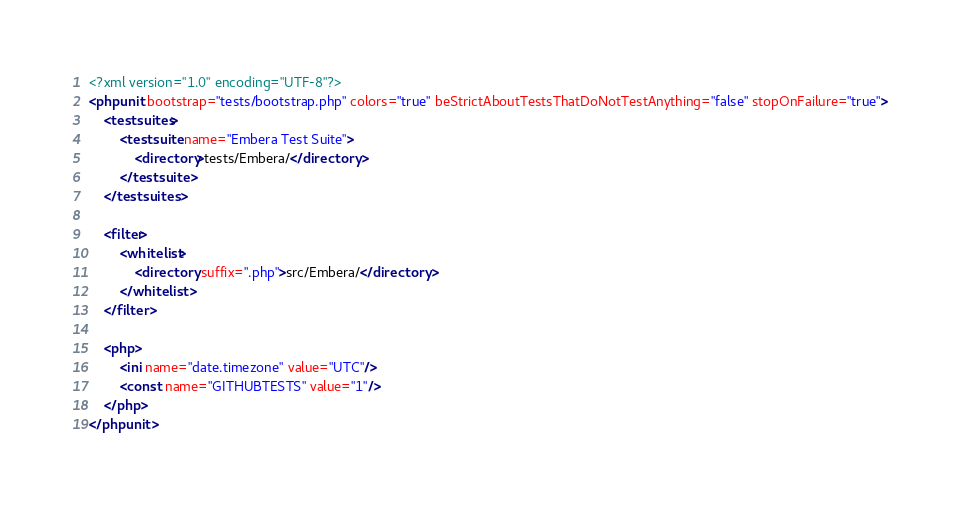Convert code to text. <code><loc_0><loc_0><loc_500><loc_500><_XML_><?xml version="1.0" encoding="UTF-8"?>
<phpunit bootstrap="tests/bootstrap.php" colors="true" beStrictAboutTestsThatDoNotTestAnything="false" stopOnFailure="true">
    <testsuites>
        <testsuite name="Embera Test Suite">
            <directory>tests/Embera/</directory>
        </testsuite>
    </testsuites>

    <filter>
        <whitelist>
            <directory suffix=".php">src/Embera/</directory>
        </whitelist>
    </filter>

    <php>
        <ini name="date.timezone" value="UTC"/>
        <const name="GITHUBTESTS" value="1"/>
    </php>
</phpunit>
</code> 